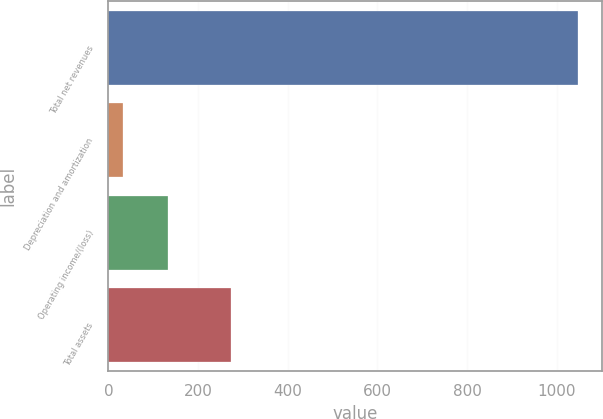Convert chart. <chart><loc_0><loc_0><loc_500><loc_500><bar_chart><fcel>Total net revenues<fcel>Depreciation and amortization<fcel>Operating income/(loss)<fcel>Total assets<nl><fcel>1048<fcel>31.7<fcel>133.33<fcel>273.8<nl></chart> 